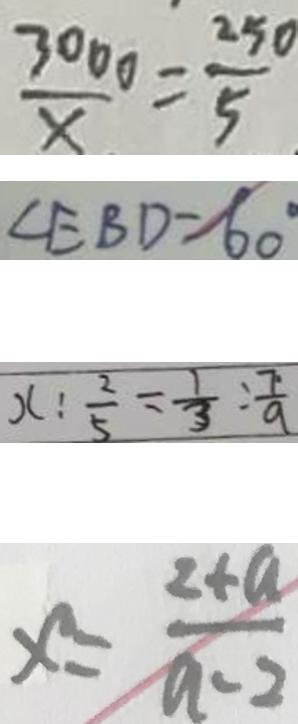<formula> <loc_0><loc_0><loc_500><loc_500>\frac { 3 0 0 0 } { x } = \frac { 2 5 0 } { 5 } 
 \angle E B D = 6 0 ^ { \circ } 
 x : \frac { 2 } { 5 } = \frac { 1 } { 3 } : \frac { 7 } { 9 } 
 x = \frac { 2 + a } { a - 2 }</formula> 